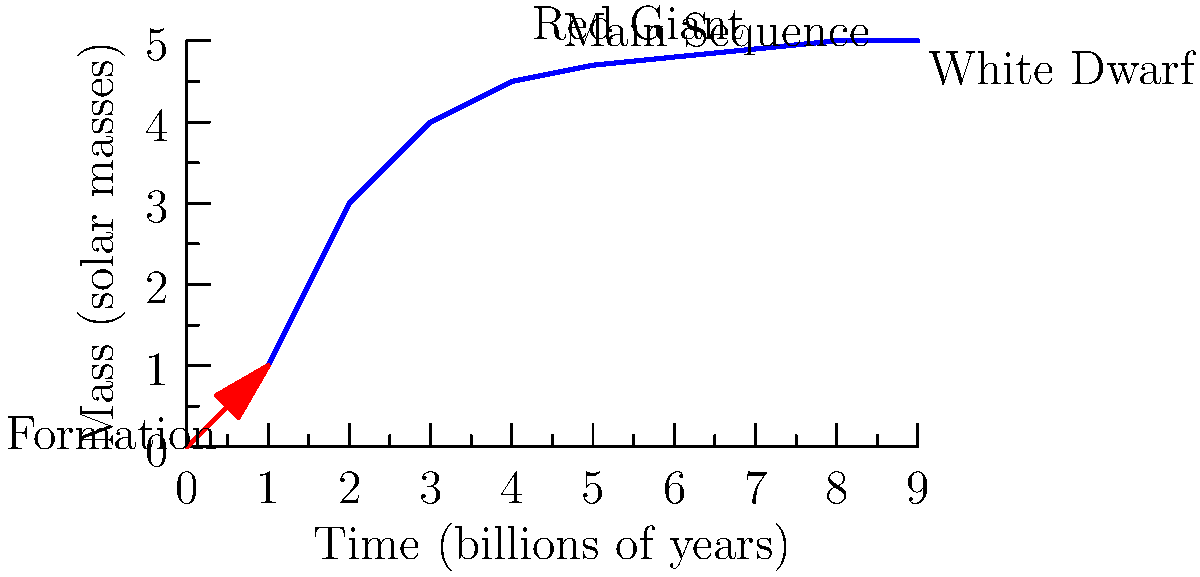In the life cycle of a star similar to our Sun, which phase is characterized by a relatively stable period of hydrogen fusion and occupies the majority of the star's lifetime? To answer this question, let's break down the life cycle of a Sun-like star:

1. Formation: A star forms from a collapsing cloud of gas and dust, increasing in mass and temperature.

2. Main Sequence: This is the longest and most stable phase of a star's life. During this time:
   - The star fuses hydrogen into helium in its core.
   - It maintains a balance between gravity and radiation pressure.
   - For a star like our Sun, this phase lasts about 10 billion years.

3. Red Giant: After depleting its core hydrogen, the star expands and cools, becoming a red giant.

4. Planetary Nebula: The outer layers of the star are expelled, forming a planetary nebula.

5. White Dwarf: The remaining core becomes a dense, hot white dwarf that slowly cools over billions of years.

Looking at the graph, we can see that the Main Sequence occupies the longest and most stable period in the star's life, characterized by a gradual increase in mass over billions of years. This corresponds to the long, nearly horizontal section of the curve.

The Main Sequence phase is crucial because it's when a star, like our Sun, spends most of its life fusing hydrogen into helium, providing stable energy output. This stability is vital for the development of life on orbiting planets.
Answer: Main Sequence 